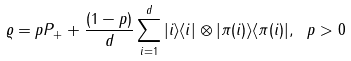<formula> <loc_0><loc_0><loc_500><loc_500>\varrho = p P _ { + } + \frac { ( 1 - p ) } { d } \sum _ { i = 1 } ^ { d } | i \rangle \langle i | \otimes | \pi ( i ) \rangle \langle \pi ( i ) | , \ p > 0</formula> 